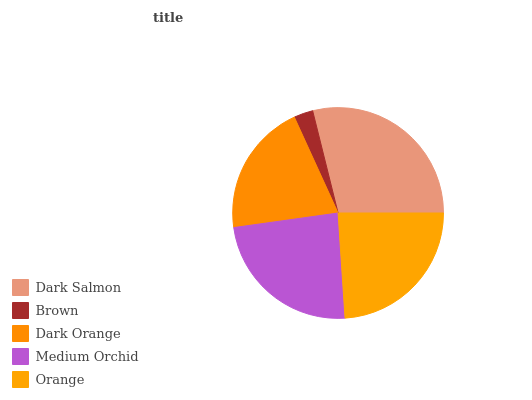Is Brown the minimum?
Answer yes or no. Yes. Is Dark Salmon the maximum?
Answer yes or no. Yes. Is Dark Orange the minimum?
Answer yes or no. No. Is Dark Orange the maximum?
Answer yes or no. No. Is Dark Orange greater than Brown?
Answer yes or no. Yes. Is Brown less than Dark Orange?
Answer yes or no. Yes. Is Brown greater than Dark Orange?
Answer yes or no. No. Is Dark Orange less than Brown?
Answer yes or no. No. Is Medium Orchid the high median?
Answer yes or no. Yes. Is Medium Orchid the low median?
Answer yes or no. Yes. Is Brown the high median?
Answer yes or no. No. Is Orange the low median?
Answer yes or no. No. 